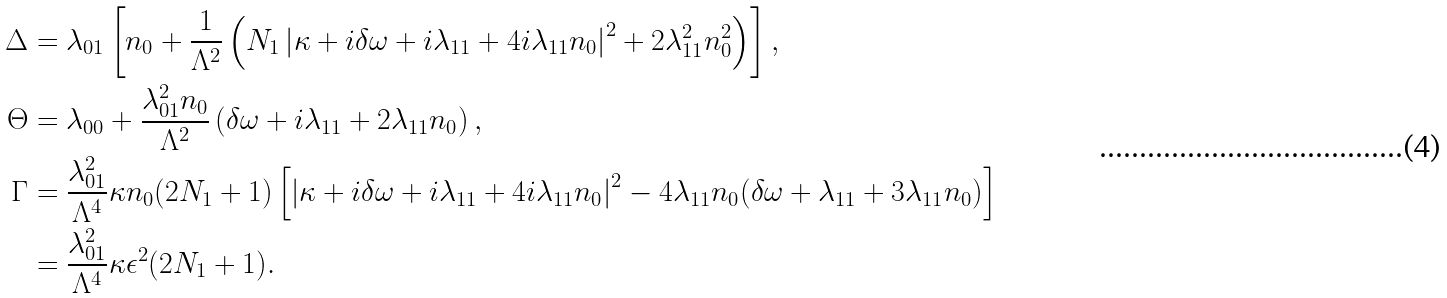<formula> <loc_0><loc_0><loc_500><loc_500>\Delta & = { \lambda _ { 0 1 } } \left [ n _ { 0 } + \frac { 1 } { \Lambda ^ { 2 } } \left ( N _ { 1 } \left | \kappa + i \delta \omega + i \lambda _ { 1 1 } + 4 i \lambda _ { 1 1 } n _ { 0 } \right | ^ { 2 } + 2 \lambda _ { 1 1 } ^ { 2 } n _ { 0 } ^ { 2 } \right ) \right ] , \\ \Theta & = \lambda _ { 0 0 } + \frac { \lambda _ { 0 1 } ^ { 2 } n _ { 0 } } { \Lambda ^ { 2 } } \left ( \delta \omega + i \lambda _ { 1 1 } + 2 \lambda _ { 1 1 } n _ { 0 } \right ) , \\ \Gamma & = \frac { \lambda _ { 0 1 } ^ { 2 } } { \Lambda ^ { 4 } } \kappa n _ { 0 } ( 2 N _ { 1 } + 1 ) \left [ \left | \kappa + i \delta \omega + i \lambda _ { 1 1 } + 4 i \lambda _ { 1 1 } n _ { 0 } \right | ^ { 2 } - 4 \lambda _ { 1 1 } n _ { 0 } ( \delta \omega + \lambda _ { 1 1 } + 3 \lambda _ { 1 1 } n _ { 0 } ) \right ] \\ & = \frac { \lambda _ { 0 1 } ^ { 2 } } { \Lambda ^ { 4 } } \kappa \epsilon ^ { 2 } ( 2 N _ { 1 } + 1 ) .</formula> 